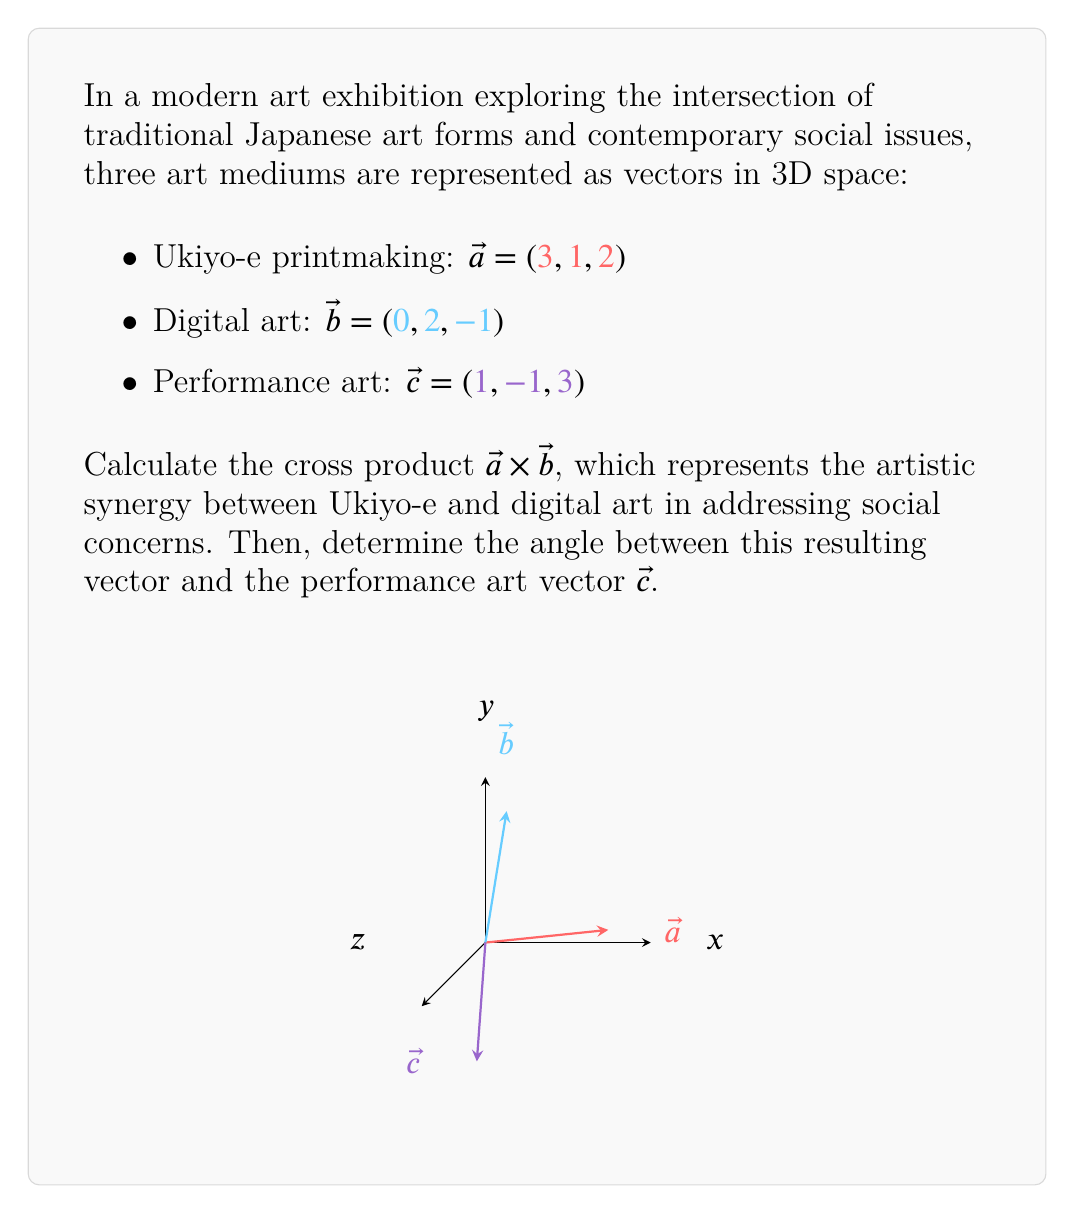Provide a solution to this math problem. Step 1: Compute the cross product $\vec{a} \times \vec{b}$

Using the determinant method:
$$\vec{a} \times \vec{b} = \begin{vmatrix}
\hat{i} & \hat{j} & \hat{k} \\
3 & 1 & 2 \\
0 & 2 & -1
\end{vmatrix}$$

$$= (1(-1) - 2(2))\hat{i} - (3(-1) - 2(0))\hat{j} + (3(2) - 1(0))\hat{k}$$

$$= (-1 - 4)\hat{i} - (-3 - 0)\hat{j} + (6 - 0)\hat{k}$$

$$= -5\hat{i} + 3\hat{j} + 6\hat{k}$$

So, $\vec{a} \times \vec{b} = (-5, 3, 6)$

Step 2: Calculate the angle between $\vec{a} \times \vec{b}$ and $\vec{c}$

Let $\vec{d} = \vec{a} \times \vec{b} = (-5, 3, 6)$

Use the dot product formula: $\cos \theta = \frac{\vec{d} \cdot \vec{c}}{|\vec{d}||\vec{c}|}$

$\vec{d} \cdot \vec{c} = (-5)(1) + (3)(-1) + (6)(3) = -5 - 3 + 18 = 10$

$|\vec{d}| = \sqrt{(-5)^2 + 3^2 + 6^2} = \sqrt{25 + 9 + 36} = \sqrt{70}$

$|\vec{c}| = \sqrt{1^2 + (-1)^2 + 3^2} = \sqrt{1 + 1 + 9} = \sqrt{11}$

$\cos \theta = \frac{10}{\sqrt{70}\sqrt{11}}$

$\theta = \arccos(\frac{10}{\sqrt{770}})$
Answer: $\vec{a} \times \vec{b} = (-5, 3, 6)$; $\theta = \arccos(\frac{10}{\sqrt{770}})$ 